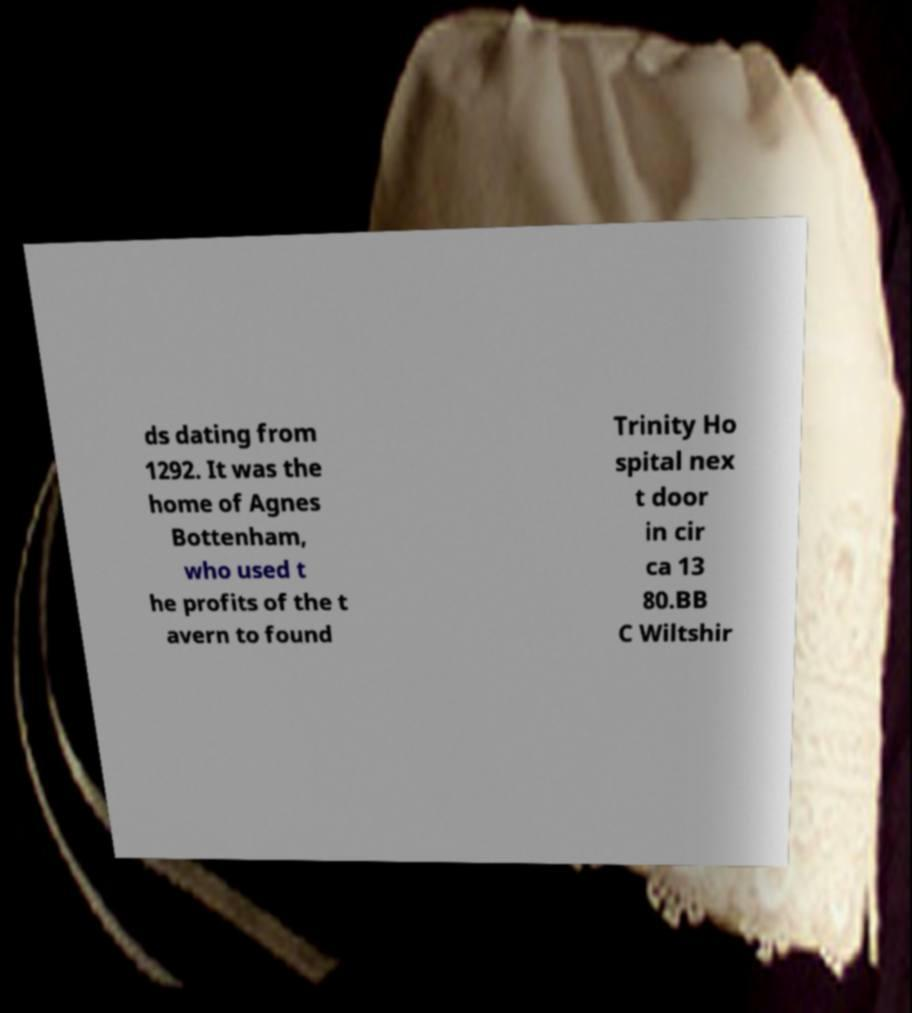I need the written content from this picture converted into text. Can you do that? ds dating from 1292. It was the home of Agnes Bottenham, who used t he profits of the t avern to found Trinity Ho spital nex t door in cir ca 13 80.BB C Wiltshir 